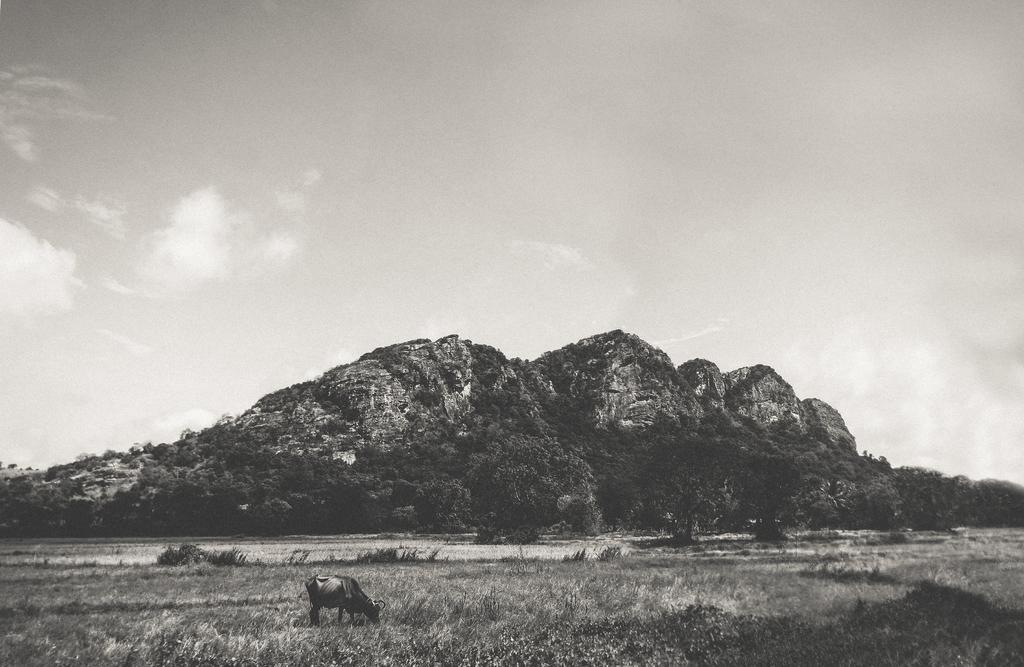Describe this image in one or two sentences. In this picture I can see trees and a hill and I can see grass on the ground and a cow grazing grass and I can see a cloudy sky. 